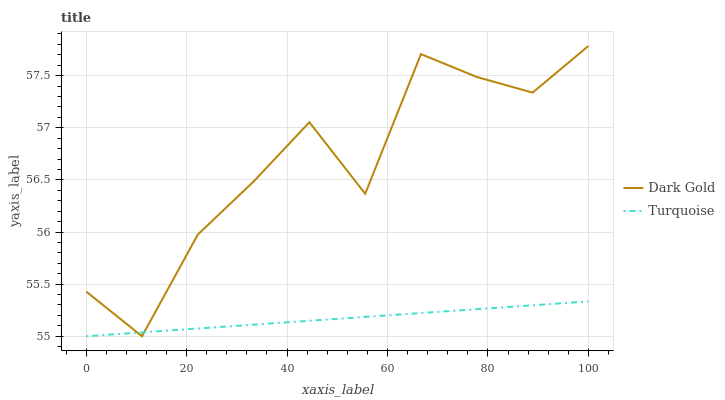Does Turquoise have the minimum area under the curve?
Answer yes or no. Yes. Does Dark Gold have the maximum area under the curve?
Answer yes or no. Yes. Does Dark Gold have the minimum area under the curve?
Answer yes or no. No. Is Turquoise the smoothest?
Answer yes or no. Yes. Is Dark Gold the roughest?
Answer yes or no. Yes. Is Dark Gold the smoothest?
Answer yes or no. No. Does Turquoise have the lowest value?
Answer yes or no. Yes. Does Dark Gold have the highest value?
Answer yes or no. Yes. Does Dark Gold intersect Turquoise?
Answer yes or no. Yes. Is Dark Gold less than Turquoise?
Answer yes or no. No. Is Dark Gold greater than Turquoise?
Answer yes or no. No. 